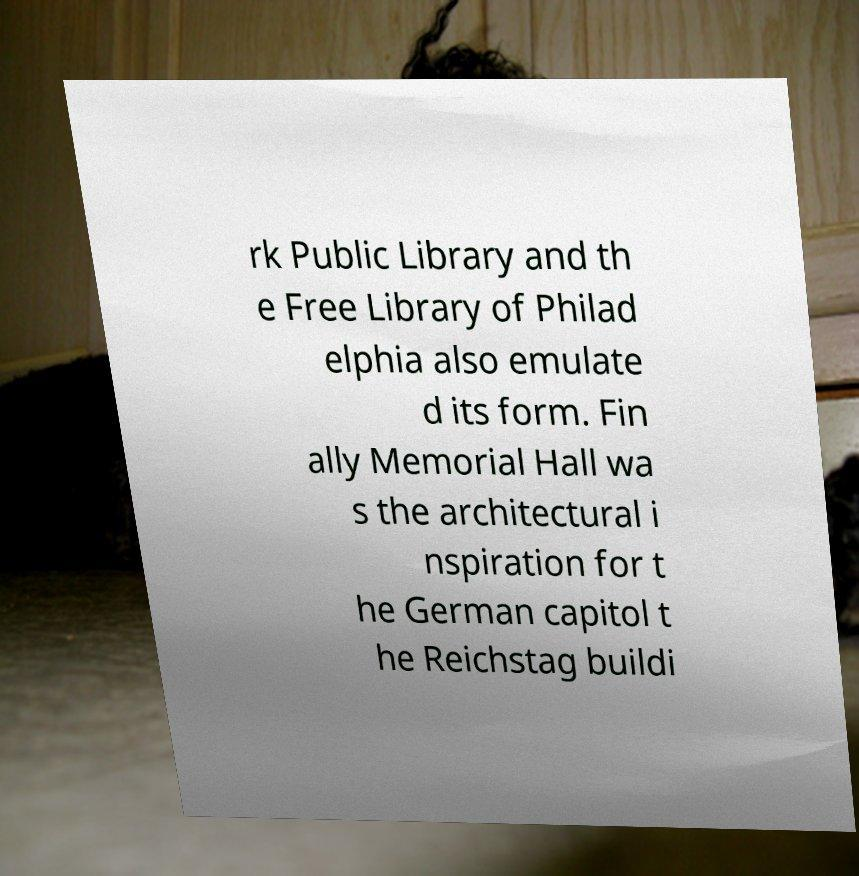I need the written content from this picture converted into text. Can you do that? rk Public Library and th e Free Library of Philad elphia also emulate d its form. Fin ally Memorial Hall wa s the architectural i nspiration for t he German capitol t he Reichstag buildi 